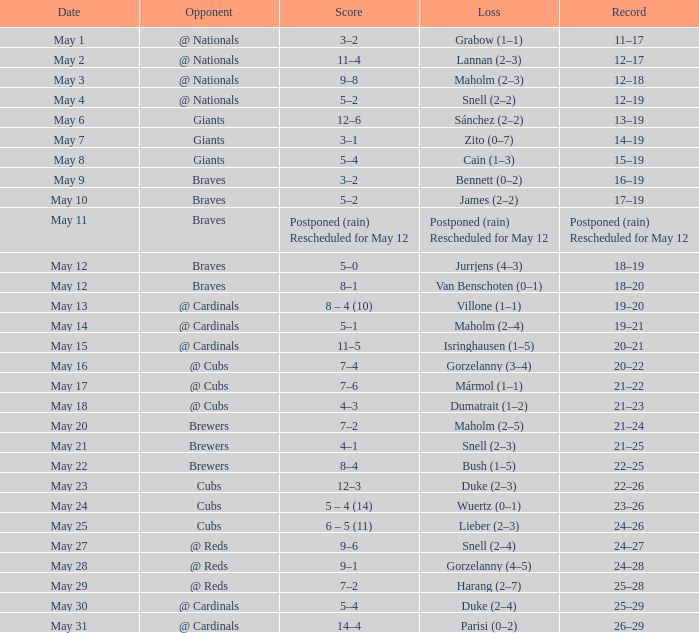What was the score of the game with a loss of Maholm (2–4)? 5–1. 